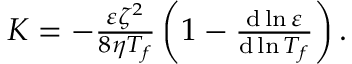Convert formula to latex. <formula><loc_0><loc_0><loc_500><loc_500>\begin{array} { r } { K = - \frac { \varepsilon \zeta ^ { 2 } } { 8 \eta T _ { f } } \left ( 1 - \frac { d \ln \varepsilon } { d \ln T _ { f } } \right ) . } \end{array}</formula> 